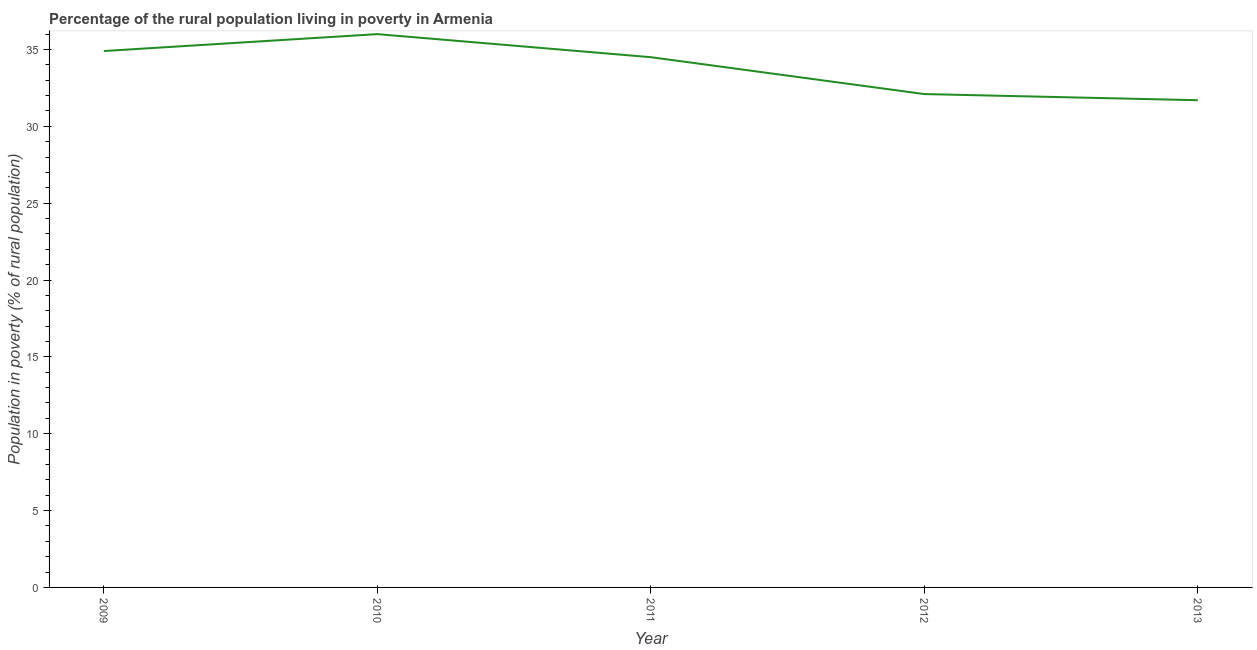What is the percentage of rural population living below poverty line in 2009?
Keep it short and to the point. 34.9. Across all years, what is the maximum percentage of rural population living below poverty line?
Provide a short and direct response. 36. Across all years, what is the minimum percentage of rural population living below poverty line?
Ensure brevity in your answer.  31.7. In which year was the percentage of rural population living below poverty line maximum?
Make the answer very short. 2010. What is the sum of the percentage of rural population living below poverty line?
Make the answer very short. 169.2. What is the difference between the percentage of rural population living below poverty line in 2012 and 2013?
Provide a short and direct response. 0.4. What is the average percentage of rural population living below poverty line per year?
Ensure brevity in your answer.  33.84. What is the median percentage of rural population living below poverty line?
Make the answer very short. 34.5. Do a majority of the years between 2011 and 2012 (inclusive) have percentage of rural population living below poverty line greater than 32 %?
Your answer should be very brief. Yes. What is the ratio of the percentage of rural population living below poverty line in 2011 to that in 2013?
Your answer should be compact. 1.09. Is the difference between the percentage of rural population living below poverty line in 2009 and 2013 greater than the difference between any two years?
Offer a terse response. No. What is the difference between the highest and the second highest percentage of rural population living below poverty line?
Provide a succinct answer. 1.1. Is the sum of the percentage of rural population living below poverty line in 2012 and 2013 greater than the maximum percentage of rural population living below poverty line across all years?
Your answer should be compact. Yes. What is the difference between the highest and the lowest percentage of rural population living below poverty line?
Give a very brief answer. 4.3. In how many years, is the percentage of rural population living below poverty line greater than the average percentage of rural population living below poverty line taken over all years?
Your answer should be compact. 3. Does the percentage of rural population living below poverty line monotonically increase over the years?
Provide a succinct answer. No. How many lines are there?
Keep it short and to the point. 1. How many years are there in the graph?
Provide a succinct answer. 5. What is the difference between two consecutive major ticks on the Y-axis?
Your answer should be compact. 5. Are the values on the major ticks of Y-axis written in scientific E-notation?
Offer a terse response. No. What is the title of the graph?
Offer a terse response. Percentage of the rural population living in poverty in Armenia. What is the label or title of the Y-axis?
Your answer should be compact. Population in poverty (% of rural population). What is the Population in poverty (% of rural population) of 2009?
Provide a short and direct response. 34.9. What is the Population in poverty (% of rural population) of 2010?
Provide a short and direct response. 36. What is the Population in poverty (% of rural population) in 2011?
Make the answer very short. 34.5. What is the Population in poverty (% of rural population) in 2012?
Keep it short and to the point. 32.1. What is the Population in poverty (% of rural population) of 2013?
Ensure brevity in your answer.  31.7. What is the difference between the Population in poverty (% of rural population) in 2009 and 2011?
Provide a short and direct response. 0.4. What is the difference between the Population in poverty (% of rural population) in 2009 and 2013?
Your answer should be very brief. 3.2. What is the difference between the Population in poverty (% of rural population) in 2010 and 2011?
Your response must be concise. 1.5. What is the difference between the Population in poverty (% of rural population) in 2011 and 2013?
Keep it short and to the point. 2.8. What is the ratio of the Population in poverty (% of rural population) in 2009 to that in 2010?
Provide a succinct answer. 0.97. What is the ratio of the Population in poverty (% of rural population) in 2009 to that in 2011?
Your response must be concise. 1.01. What is the ratio of the Population in poverty (% of rural population) in 2009 to that in 2012?
Your answer should be very brief. 1.09. What is the ratio of the Population in poverty (% of rural population) in 2009 to that in 2013?
Your answer should be very brief. 1.1. What is the ratio of the Population in poverty (% of rural population) in 2010 to that in 2011?
Your answer should be compact. 1.04. What is the ratio of the Population in poverty (% of rural population) in 2010 to that in 2012?
Give a very brief answer. 1.12. What is the ratio of the Population in poverty (% of rural population) in 2010 to that in 2013?
Your response must be concise. 1.14. What is the ratio of the Population in poverty (% of rural population) in 2011 to that in 2012?
Make the answer very short. 1.07. What is the ratio of the Population in poverty (% of rural population) in 2011 to that in 2013?
Offer a very short reply. 1.09. 